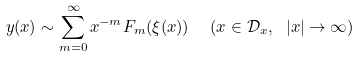Convert formula to latex. <formula><loc_0><loc_0><loc_500><loc_500>y ( x ) \sim \sum _ { m = 0 } ^ { \infty } x ^ { - m } F _ { m } ( \xi ( x ) ) \ \ ( x \in \mathcal { D } _ { x } , \ | x | \rightarrow \infty )</formula> 